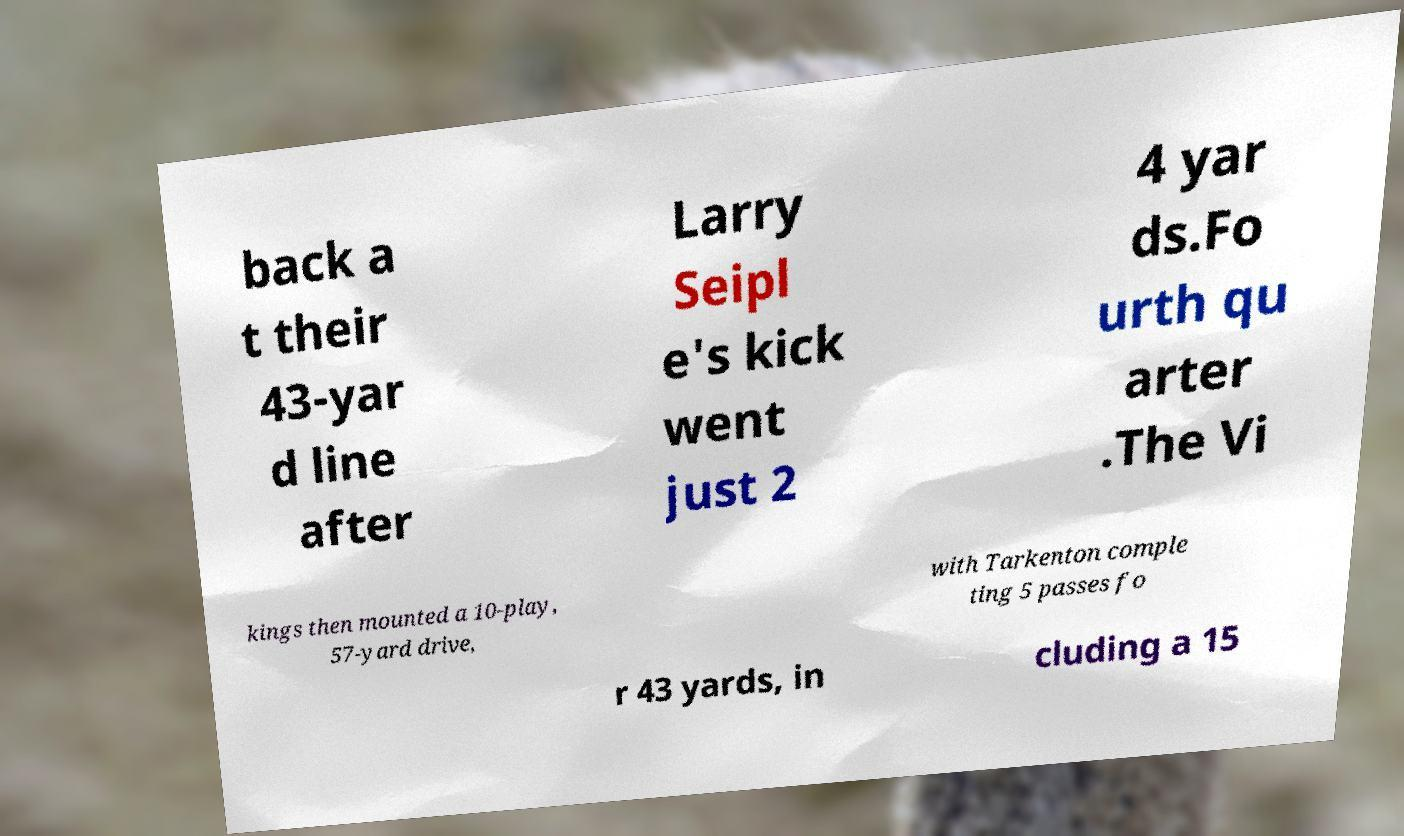I need the written content from this picture converted into text. Can you do that? back a t their 43-yar d line after Larry Seipl e's kick went just 2 4 yar ds.Fo urth qu arter .The Vi kings then mounted a 10-play, 57-yard drive, with Tarkenton comple ting 5 passes fo r 43 yards, in cluding a 15 